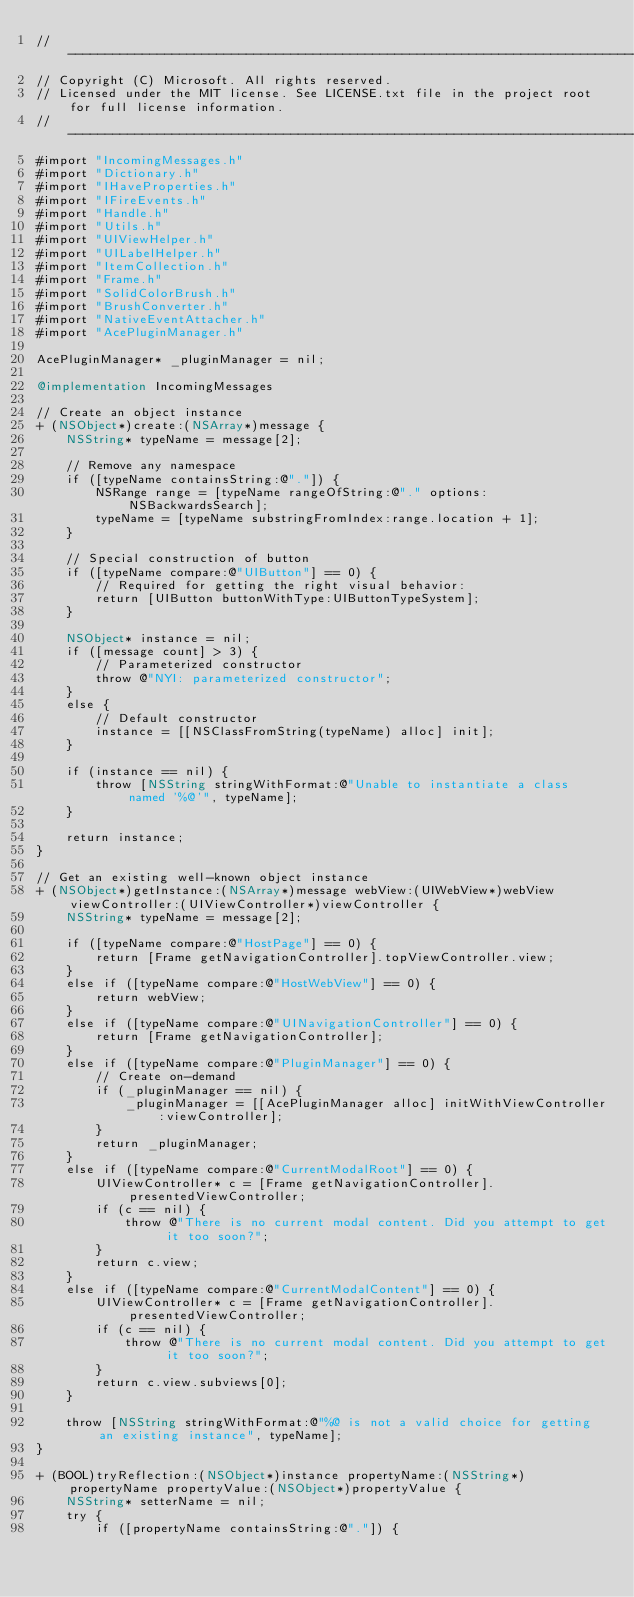Convert code to text. <code><loc_0><loc_0><loc_500><loc_500><_ObjectiveC_>//-------------------------------------------------------------------------------------------------------
// Copyright (C) Microsoft. All rights reserved.
// Licensed under the MIT license. See LICENSE.txt file in the project root for full license information.
//-------------------------------------------------------------------------------------------------------
#import "IncomingMessages.h"
#import "Dictionary.h"
#import "IHaveProperties.h"
#import "IFireEvents.h"
#import "Handle.h"
#import "Utils.h"
#import "UIViewHelper.h"
#import "UILabelHelper.h"
#import "ItemCollection.h"
#import "Frame.h"
#import "SolidColorBrush.h"
#import "BrushConverter.h"
#import "NativeEventAttacher.h"
#import "AcePluginManager.h"

AcePluginManager* _pluginManager = nil;

@implementation IncomingMessages

// Create an object instance
+ (NSObject*)create:(NSArray*)message {
    NSString* typeName = message[2];

    // Remove any namespace
    if ([typeName containsString:@"."]) {
        NSRange range = [typeName rangeOfString:@"." options:NSBackwardsSearch];
        typeName = [typeName substringFromIndex:range.location + 1];
    }

    // Special construction of button
    if ([typeName compare:@"UIButton"] == 0) {
        // Required for getting the right visual behavior:
        return [UIButton buttonWithType:UIButtonTypeSystem];
    }

    NSObject* instance = nil;
    if ([message count] > 3) {
        // Parameterized constructor
        throw @"NYI: parameterized constructor";
    }
    else {
        // Default constructor
        instance = [[NSClassFromString(typeName) alloc] init];
    }

    if (instance == nil) {
        throw [NSString stringWithFormat:@"Unable to instantiate a class named '%@'", typeName];
    }

    return instance;
}

// Get an existing well-known object instance
+ (NSObject*)getInstance:(NSArray*)message webView:(UIWebView*)webView viewController:(UIViewController*)viewController {
    NSString* typeName = message[2];

    if ([typeName compare:@"HostPage"] == 0) {
        return [Frame getNavigationController].topViewController.view;
    }
    else if ([typeName compare:@"HostWebView"] == 0) {
        return webView;
    }
    else if ([typeName compare:@"UINavigationController"] == 0) {
        return [Frame getNavigationController];
    }
    else if ([typeName compare:@"PluginManager"] == 0) {
        // Create on-demand
        if (_pluginManager == nil) {
            _pluginManager = [[AcePluginManager alloc] initWithViewController:viewController];
        }
        return _pluginManager;
    }
    else if ([typeName compare:@"CurrentModalRoot"] == 0) {
        UIViewController* c = [Frame getNavigationController].presentedViewController;
        if (c == nil) {
            throw @"There is no current modal content. Did you attempt to get it too soon?";
        }
        return c.view;
    }
    else if ([typeName compare:@"CurrentModalContent"] == 0) {
        UIViewController* c = [Frame getNavigationController].presentedViewController;
        if (c == nil) {
            throw @"There is no current modal content. Did you attempt to get it too soon?";
        }
        return c.view.subviews[0];
    }

    throw [NSString stringWithFormat:@"%@ is not a valid choice for getting an existing instance", typeName];
}

+ (BOOL)tryReflection:(NSObject*)instance propertyName:(NSString*)propertyName propertyValue:(NSObject*)propertyValue {
    NSString* setterName = nil;
    try {
        if ([propertyName containsString:@"."]) {</code> 